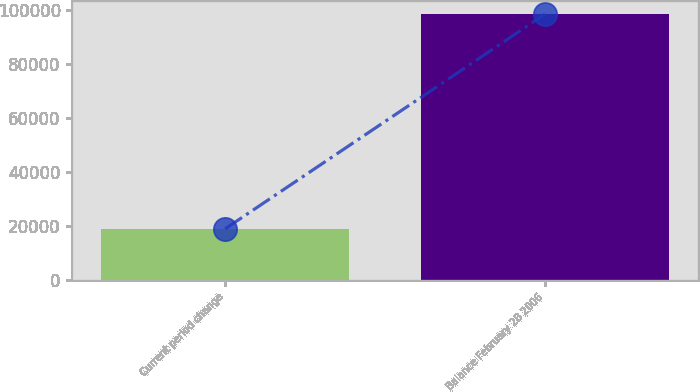<chart> <loc_0><loc_0><loc_500><loc_500><bar_chart><fcel>Current period change<fcel>Balance February 28 2006<nl><fcel>18892<fcel>98314<nl></chart> 